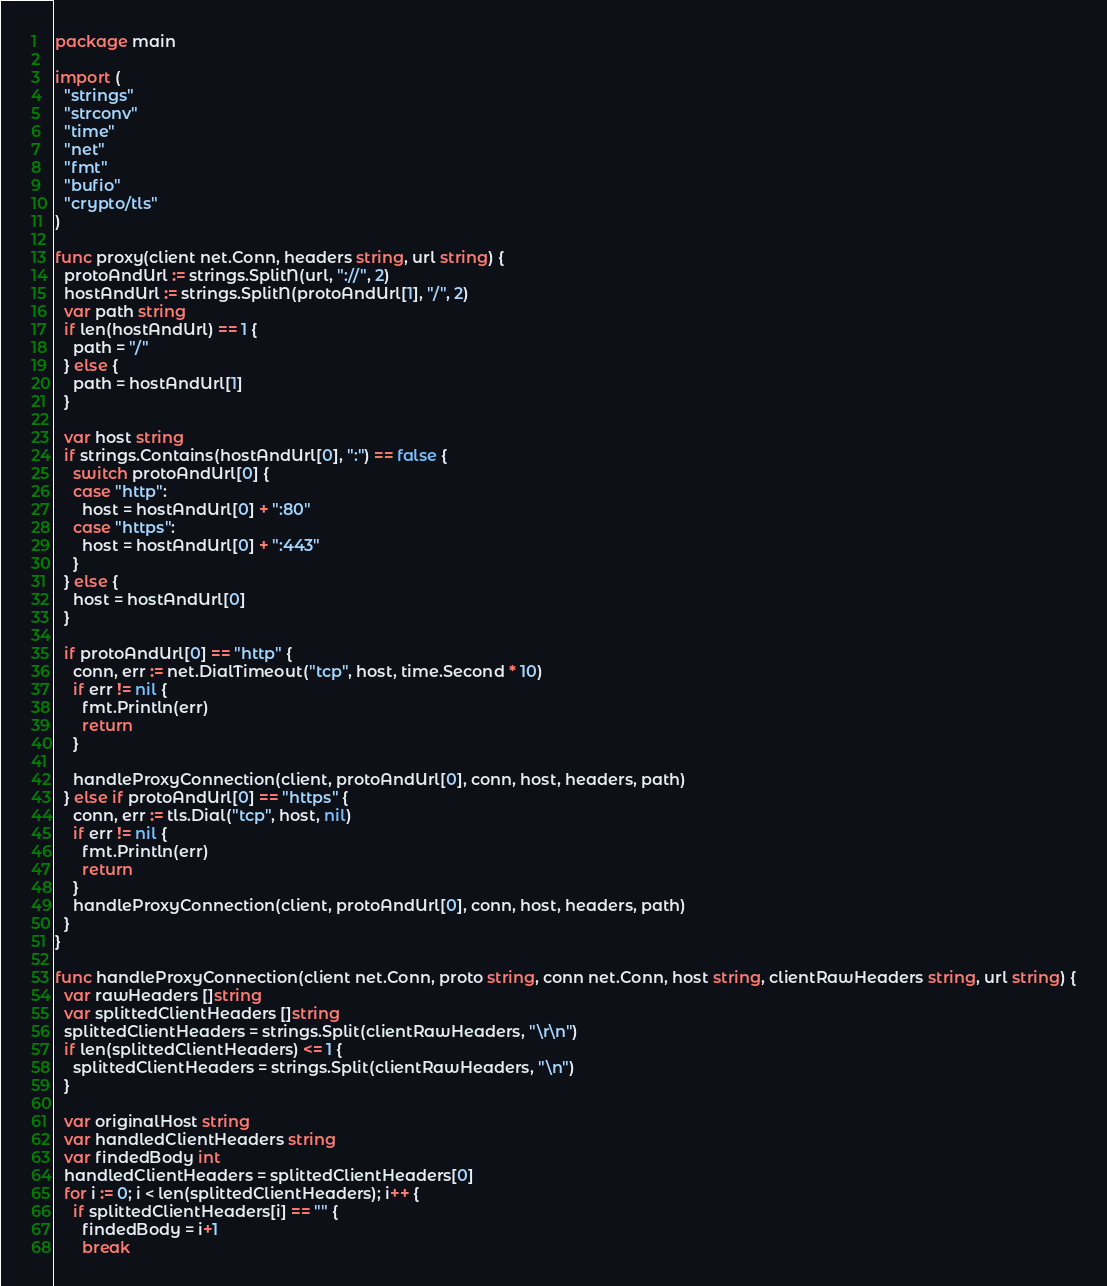<code> <loc_0><loc_0><loc_500><loc_500><_Go_>package main

import (
  "strings"
  "strconv"
  "time"
  "net"
  "fmt"
  "bufio"
  "crypto/tls"
)

func proxy(client net.Conn, headers string, url string) {
  protoAndUrl := strings.SplitN(url, "://", 2)
  hostAndUrl := strings.SplitN(protoAndUrl[1], "/", 2)
  var path string
  if len(hostAndUrl) == 1 {
    path = "/"
  } else {
    path = hostAndUrl[1]
  }

  var host string
  if strings.Contains(hostAndUrl[0], ":") == false {
    switch protoAndUrl[0] {
    case "http":
      host = hostAndUrl[0] + ":80"
    case "https":
      host = hostAndUrl[0] + ":443"
    }
  } else {
    host = hostAndUrl[0]
  }

  if protoAndUrl[0] == "http" {
    conn, err := net.DialTimeout("tcp", host, time.Second * 10)
    if err != nil {
      fmt.Println(err)
      return
    }

    handleProxyConnection(client, protoAndUrl[0], conn, host, headers, path)
  } else if protoAndUrl[0] == "https" {
    conn, err := tls.Dial("tcp", host, nil)
    if err != nil {
      fmt.Println(err)
      return
    }
    handleProxyConnection(client, protoAndUrl[0], conn, host, headers, path)
  }
}

func handleProxyConnection(client net.Conn, proto string, conn net.Conn, host string, clientRawHeaders string, url string) {
  var rawHeaders []string
  var splittedClientHeaders []string
  splittedClientHeaders = strings.Split(clientRawHeaders, "\r\n")
  if len(splittedClientHeaders) <= 1 {
    splittedClientHeaders = strings.Split(clientRawHeaders, "\n")
  }

  var originalHost string
  var handledClientHeaders string
  var findedBody int
  handledClientHeaders = splittedClientHeaders[0]
  for i := 0; i < len(splittedClientHeaders); i++ {
    if splittedClientHeaders[i] == "" {
      findedBody = i+1
      break</code> 